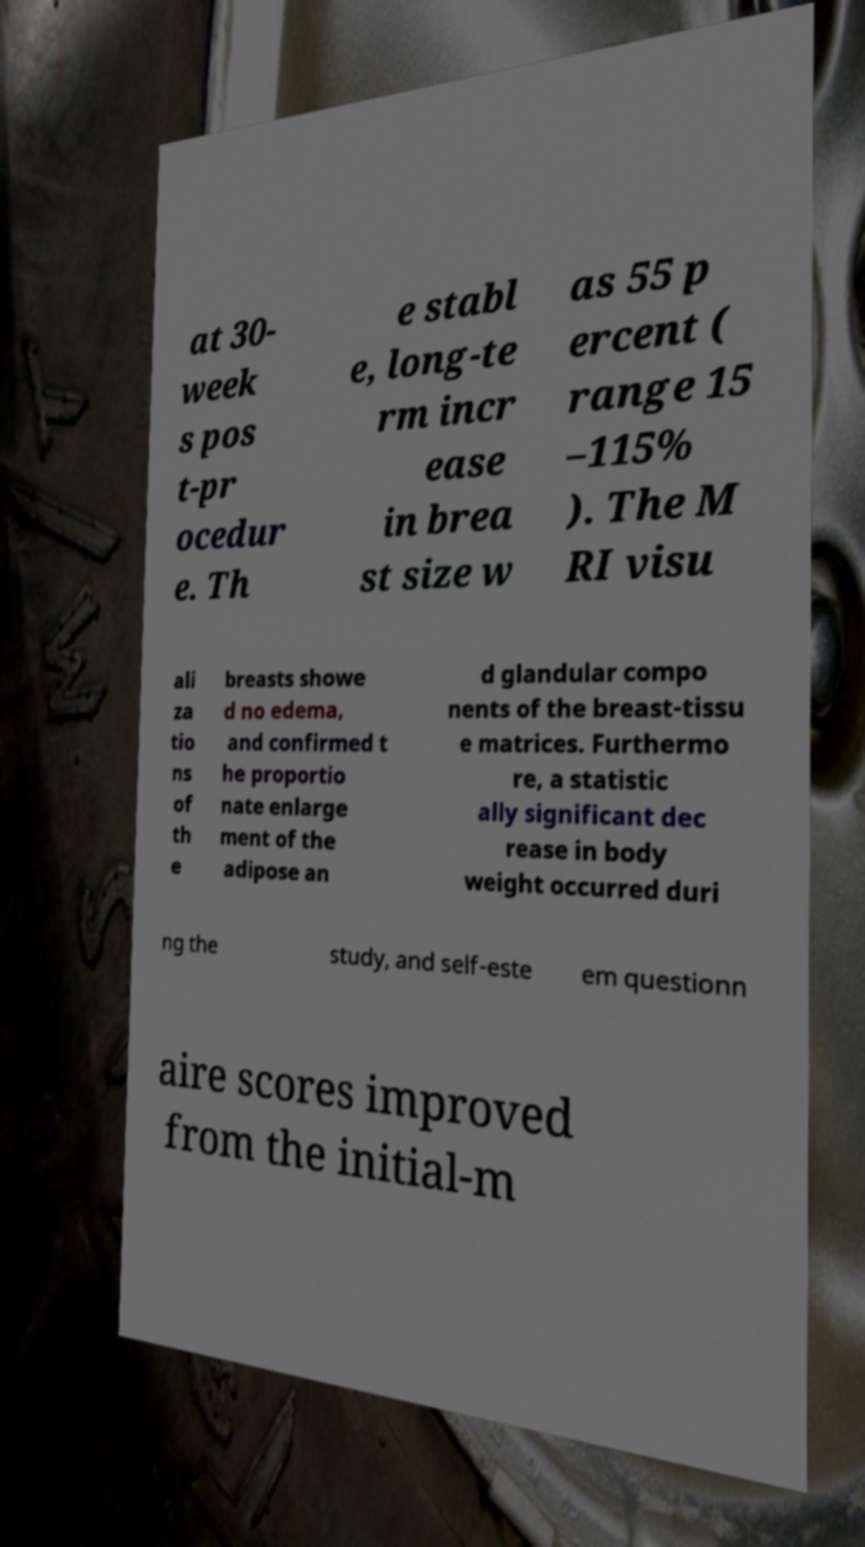Could you assist in decoding the text presented in this image and type it out clearly? at 30- week s pos t-pr ocedur e. Th e stabl e, long-te rm incr ease in brea st size w as 55 p ercent ( range 15 –115% ). The M RI visu ali za tio ns of th e breasts showe d no edema, and confirmed t he proportio nate enlarge ment of the adipose an d glandular compo nents of the breast-tissu e matrices. Furthermo re, a statistic ally significant dec rease in body weight occurred duri ng the study, and self-este em questionn aire scores improved from the initial-m 